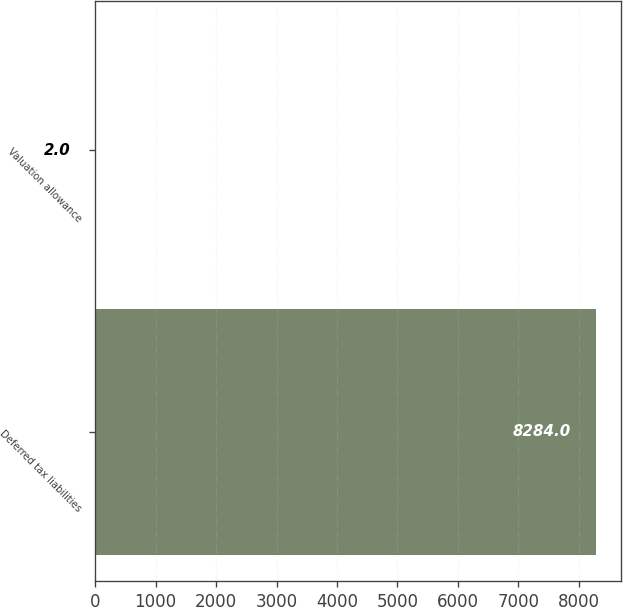Convert chart. <chart><loc_0><loc_0><loc_500><loc_500><bar_chart><fcel>Deferred tax liabilities<fcel>Valuation allowance<nl><fcel>8284<fcel>2<nl></chart> 